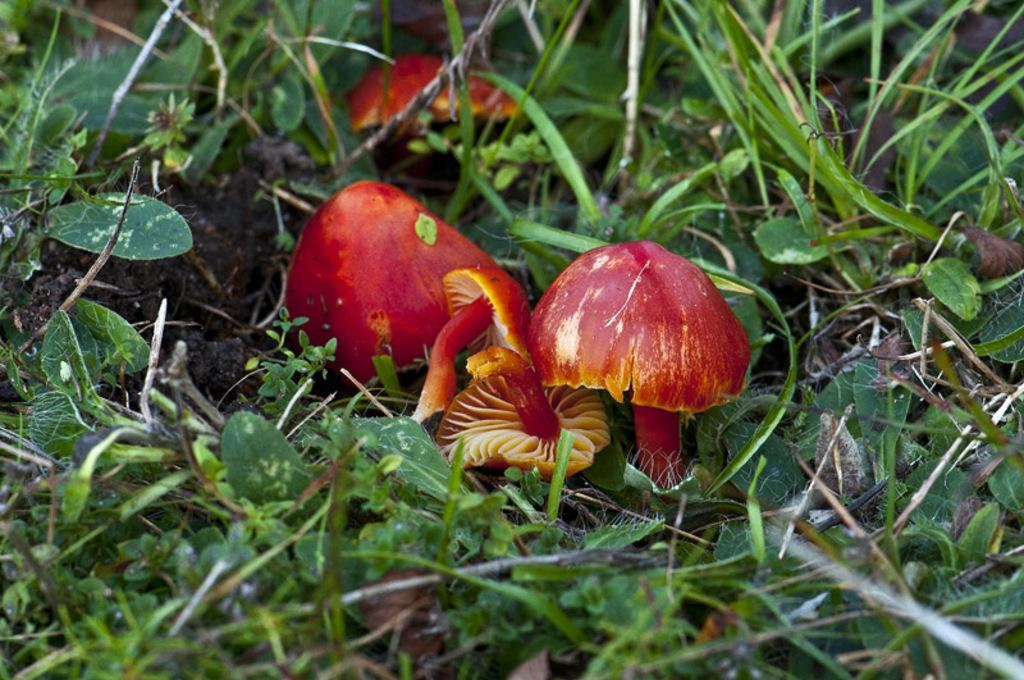What type of vegetation is present on the ground in the image? There are mushrooms on the ground in the image. What other type of vegetation can be seen in the image? There is grass in the image. Are there any other plants visible in the image? Yes, there are plants in the image. What rate is the donkey moving at in the image? There is no donkey present in the image, so it is not possible to determine its movement rate. 